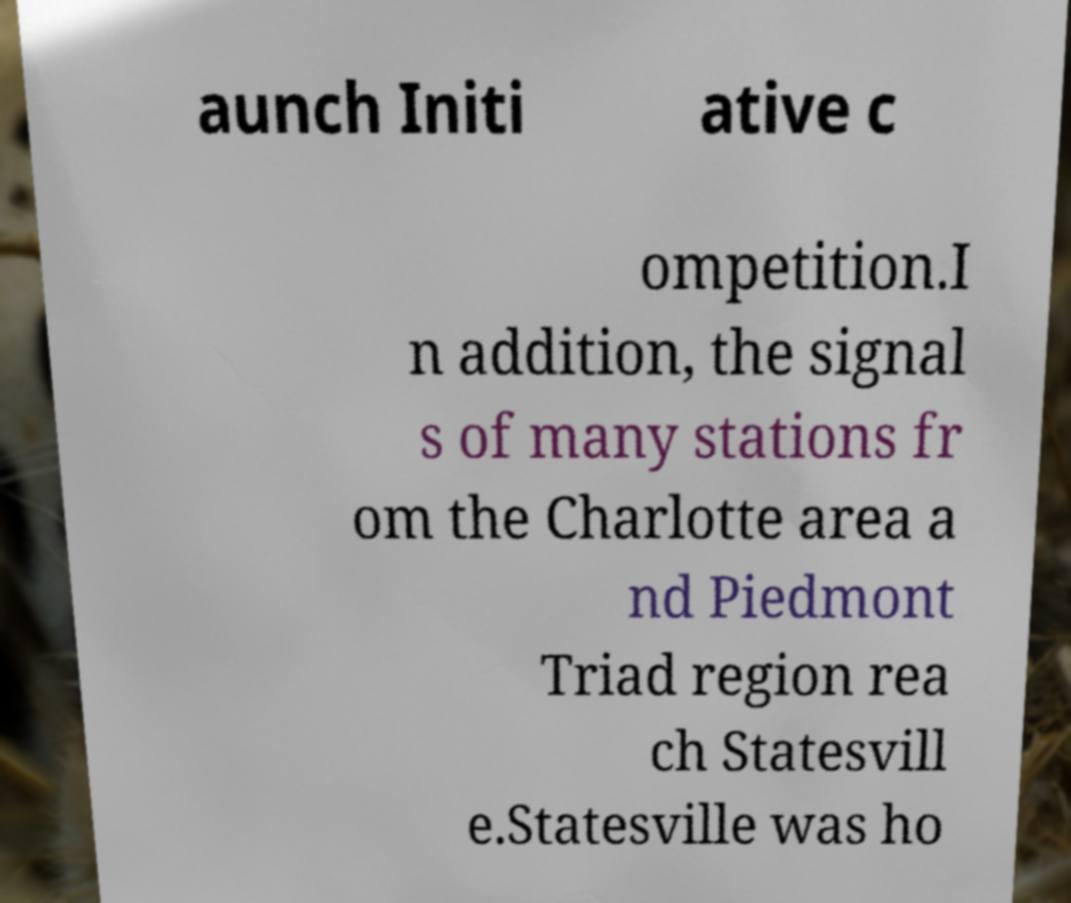What messages or text are displayed in this image? I need them in a readable, typed format. aunch Initi ative c ompetition.I n addition, the signal s of many stations fr om the Charlotte area a nd Piedmont Triad region rea ch Statesvill e.Statesville was ho 